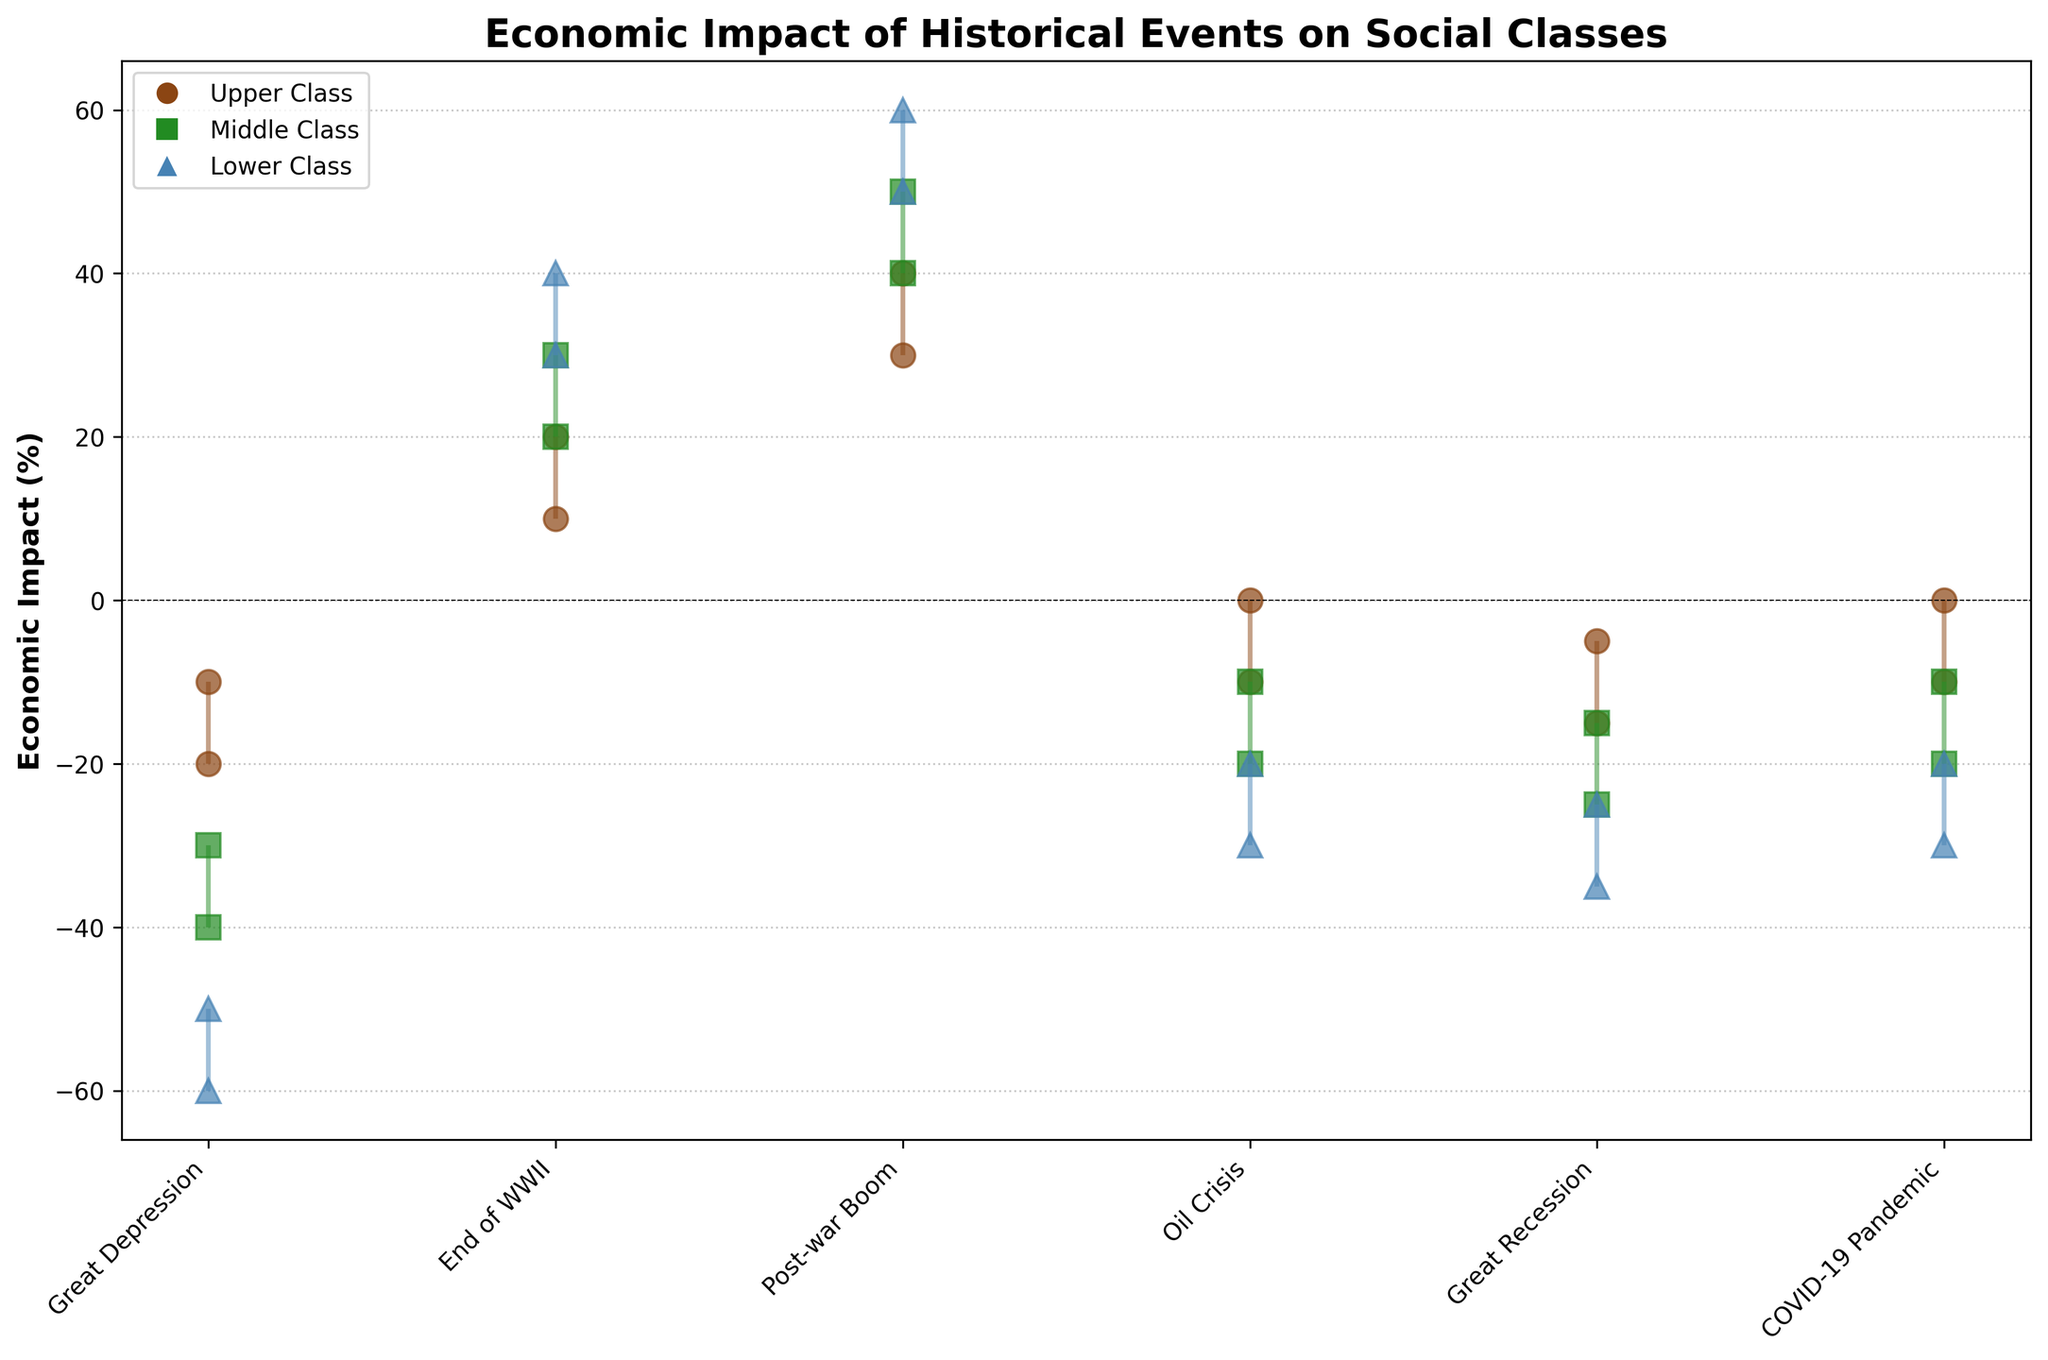What is the economic impact range of the Great Depression on the Lower Class? Look at the vertical line representing the economic impact for the Lower Class during the Great Depression. It starts at -60 and ends at -50.
Answer: -60 to -50 Which social class had the highest positive economic impact during the End of WWII? The upper, middle, and lower classes all have economic impact ranges for the End of WWII. The Lower Class shows the highest range from 30 to 40.
Answer: Lower Class How did the Middle Class fare economically during the Great Recession? Observe the range for the Middle Class during the Great Recession, which shows a negative impact from -25 to -15.
Answer: -25 to -15 Compare the economic impact range of the Upper Class during the Oil Crisis and the COVID-19 Pandemic. Which period had a less negative impact? The Upper Class during the Oil Crisis ranges from -10 to 0, and during the COVID-19 Pandemic from -10 to 0. Both periods had the same range.
Answer: Same range During which historical event did the social classes experience the most positive economic impact? Compare all events for the economic impact ranges across social classes. The 1950s Post-war Boom shows the highest positive impact for all classes, with ranges 30-40 (Upper), 40-50 (Middle), and 50-60 (Lower).
Answer: Post-war Boom (1950s) What is the difference in the economic impact between the Upper and Lower Classes during the Great Depression? Subtract the Upper Class range (-20 to -10) from the Lower Class range (-60 to -50). Considering the midpoint values (Upper Class midpoint: -15, Lower Class midpoint: -55), the difference is -55 - (-15) = -40.
Answer: 40 Which social class showed the least negative impact during the Great Recession? Examine the ranges for each class: Upper (-15 to -5), Middle (-25 to -15), Lower (-35 to -25). The Upper Class has the least negative range.
Answer: Upper Class How does the Upper Class economic impact during the Great Depression compare to the Middle Class during the same event? The Great Depression shows the Upper Class range from -20 to -10 and the Middle Class from -40 to -30. The Upper Class had a less negative impact compared to the Middle Class.
Answer: Less negative for Upper Class Which event shows a positive economic impact for the Lower Class? Identify events where the Lower Class range is above 0. The End of WWII and Post-war Boom both show positive impacts.
Answer: End of WWII, Post-war Boom What is the impact range for the Middle Class during the Post-war Boom? Look at the Middle Class segment during the Post-war Boom, which ranges from 40 to 50.
Answer: 40 to 50 